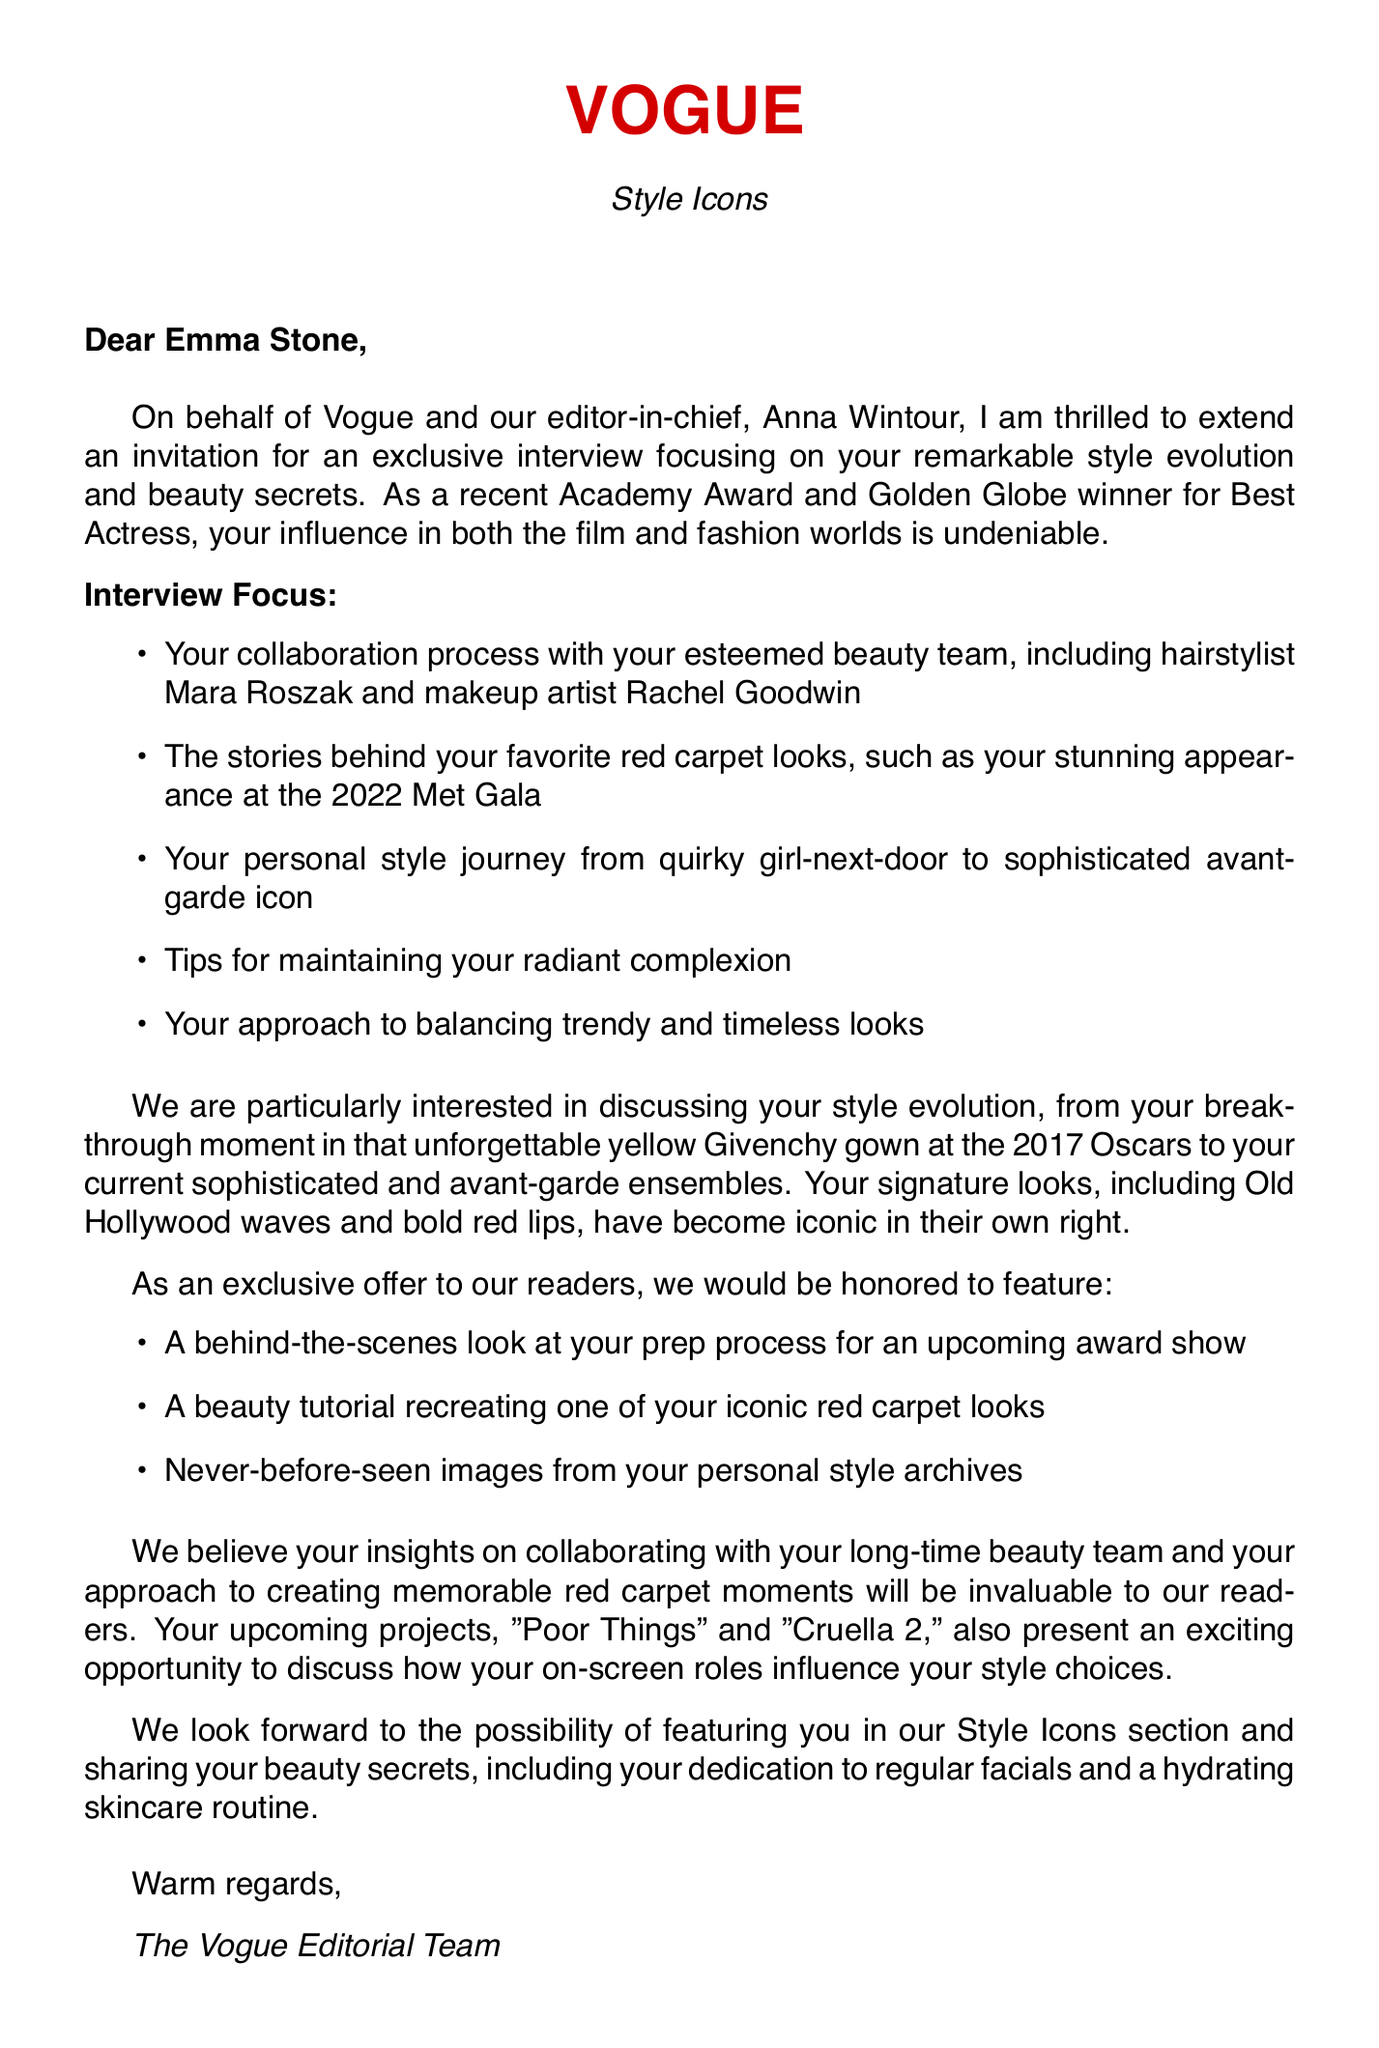What is the name of the magazine? The document mentions that the request is from Vogue.
Answer: Vogue Who is the editor-in-chief? The editor-in-chief of the magazine is mentioned in the document.
Answer: Anna Wintour What are Emma Stone's recent accolades? The document lists her recent awards as part of her introduction.
Answer: Academy Award for Best Actress, Golden Globe for Best Actress How many years has Emma collaborated with her beauty team? The document states the duration of Emma's collaboration with her hairstylist and makeup artist.
Answer: 12 What is Emma Stone's signature hair look? The document lists different signature hair looks she has.
Answer: Old Hollywood waves What was Emma Stone's breakthrough fashion moment? The document highlights a significant event in her style evolution.
Answer: Stunning yellow Givenchy gown at 2017 Oscars What type of gown did Emma wear at the 2019 Golden Globes? The document specifies the details of her outfit for that event.
Answer: Nude Valentino gown with silver embellishments What are the names of Emma's hairstylist and makeup artist? The document provides their names alongside the acknowledgment of their collaboration.
Answer: Mara Roszak, Rachel Goodwin What exclusive content is offered in the interview? The document mentions special features that will be part of the interview.
Answer: Behind-the-scenes, beauty tutorial, personal photos What style evolution aspects does Vogue want to discuss? The document lists the various focus points for the interview.
Answer: Collaboration process, favorite red carpet looks, personal style evolution, beauty tips, balancing looks 